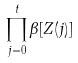Convert formula to latex. <formula><loc_0><loc_0><loc_500><loc_500>\prod _ { j = 0 } ^ { t } \beta [ Z ( j ) ]</formula> 